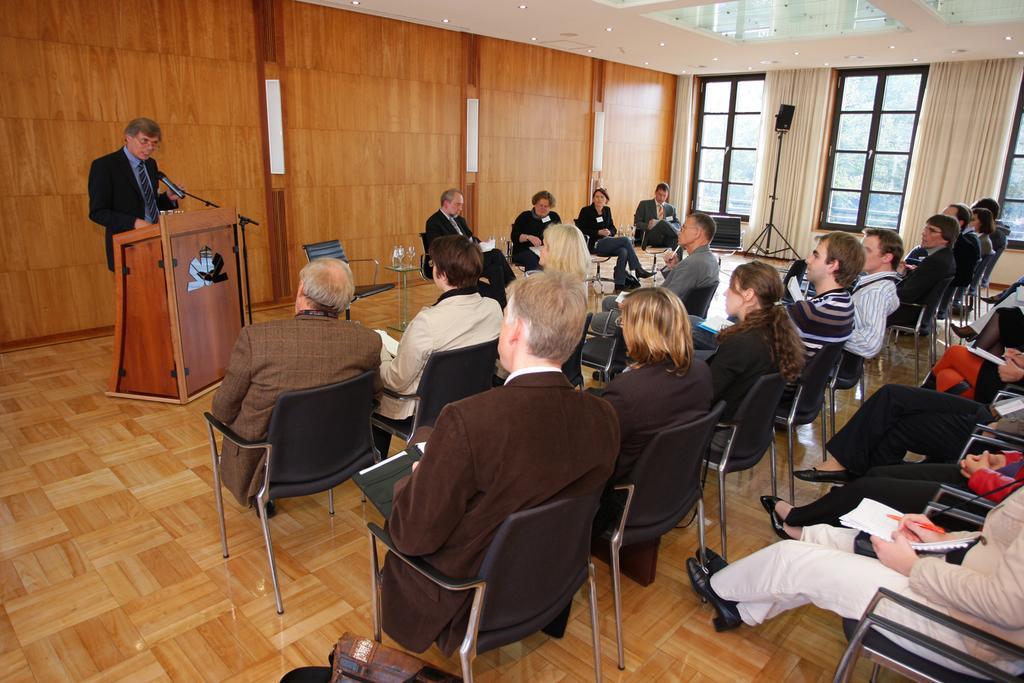Could you give a brief overview of what you see in this image? Here this is a hall with a group of people sitting in chairs, this is a speech desk and behind that there is a man standing and he is giving a speech, these are windows, these are curtains, this is speaker 